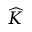Convert formula to latex. <formula><loc_0><loc_0><loc_500><loc_500>\widehat { K }</formula> 